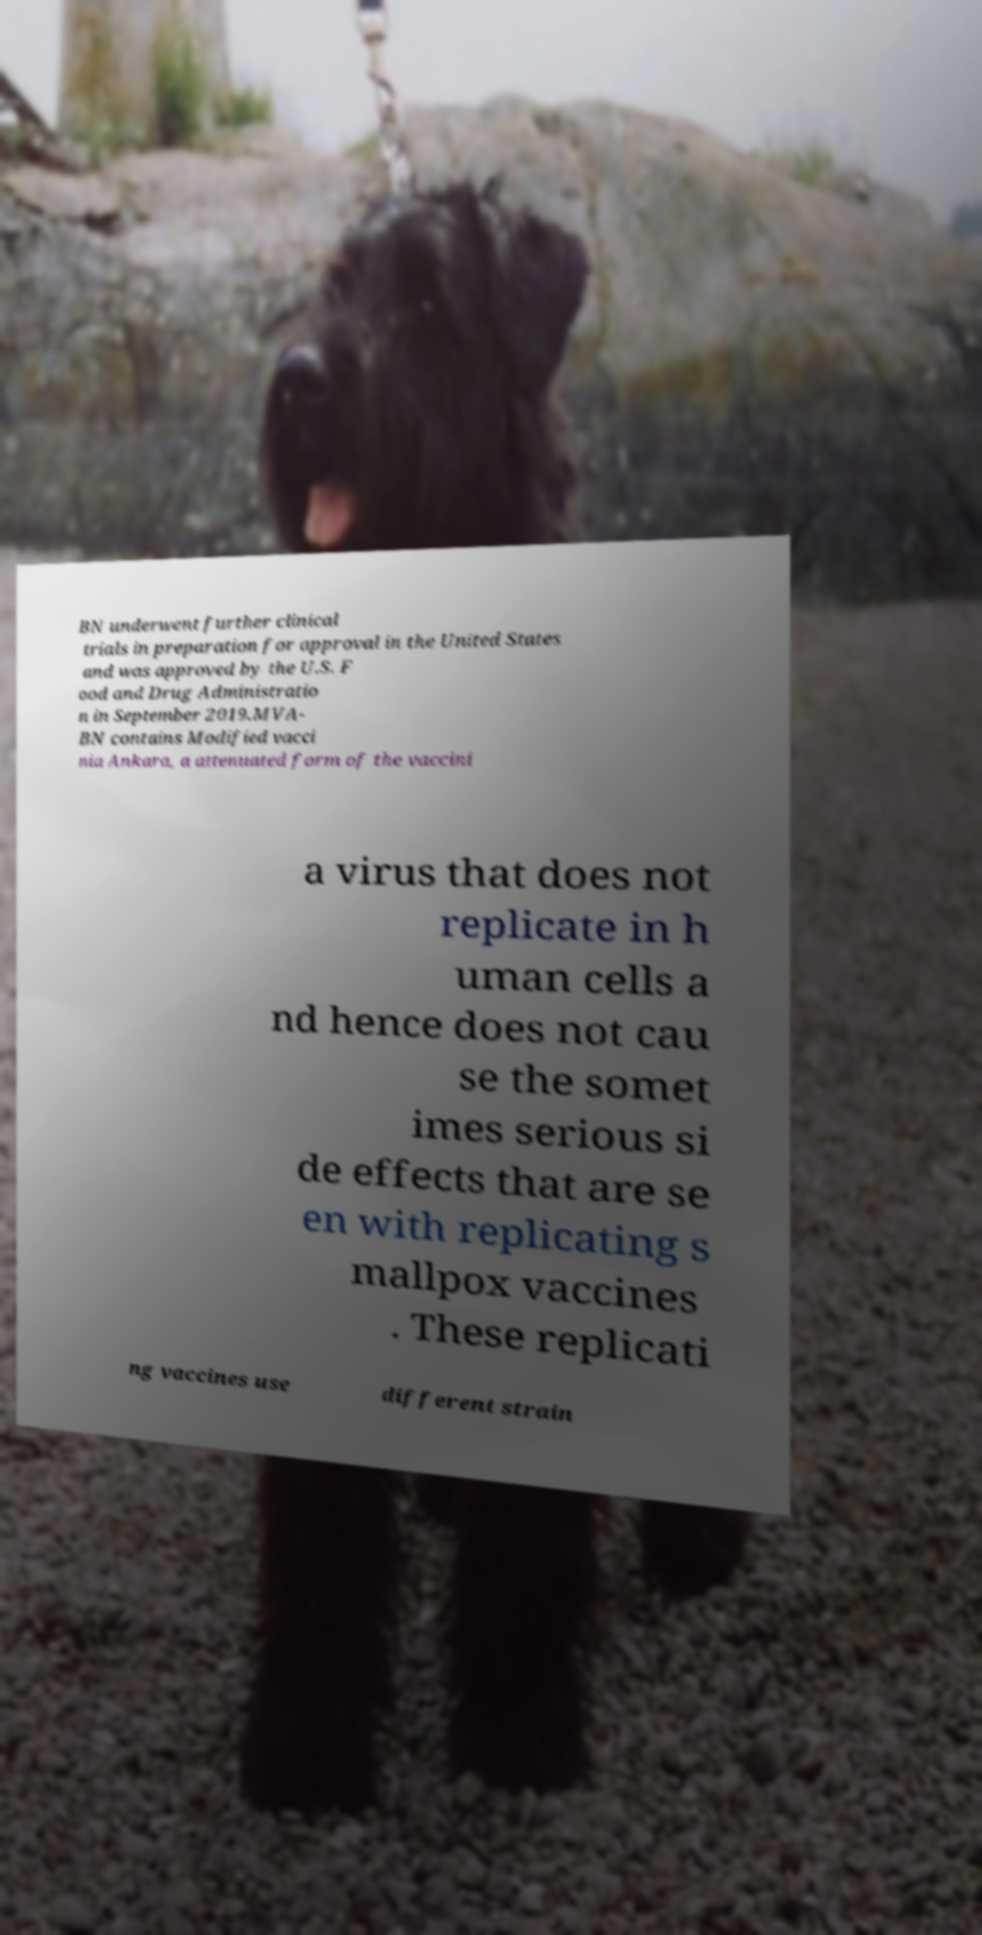Can you accurately transcribe the text from the provided image for me? BN underwent further clinical trials in preparation for approval in the United States and was approved by the U.S. F ood and Drug Administratio n in September 2019.MVA- BN contains Modified vacci nia Ankara, a attenuated form of the vaccini a virus that does not replicate in h uman cells a nd hence does not cau se the somet imes serious si de effects that are se en with replicating s mallpox vaccines . These replicati ng vaccines use different strain 